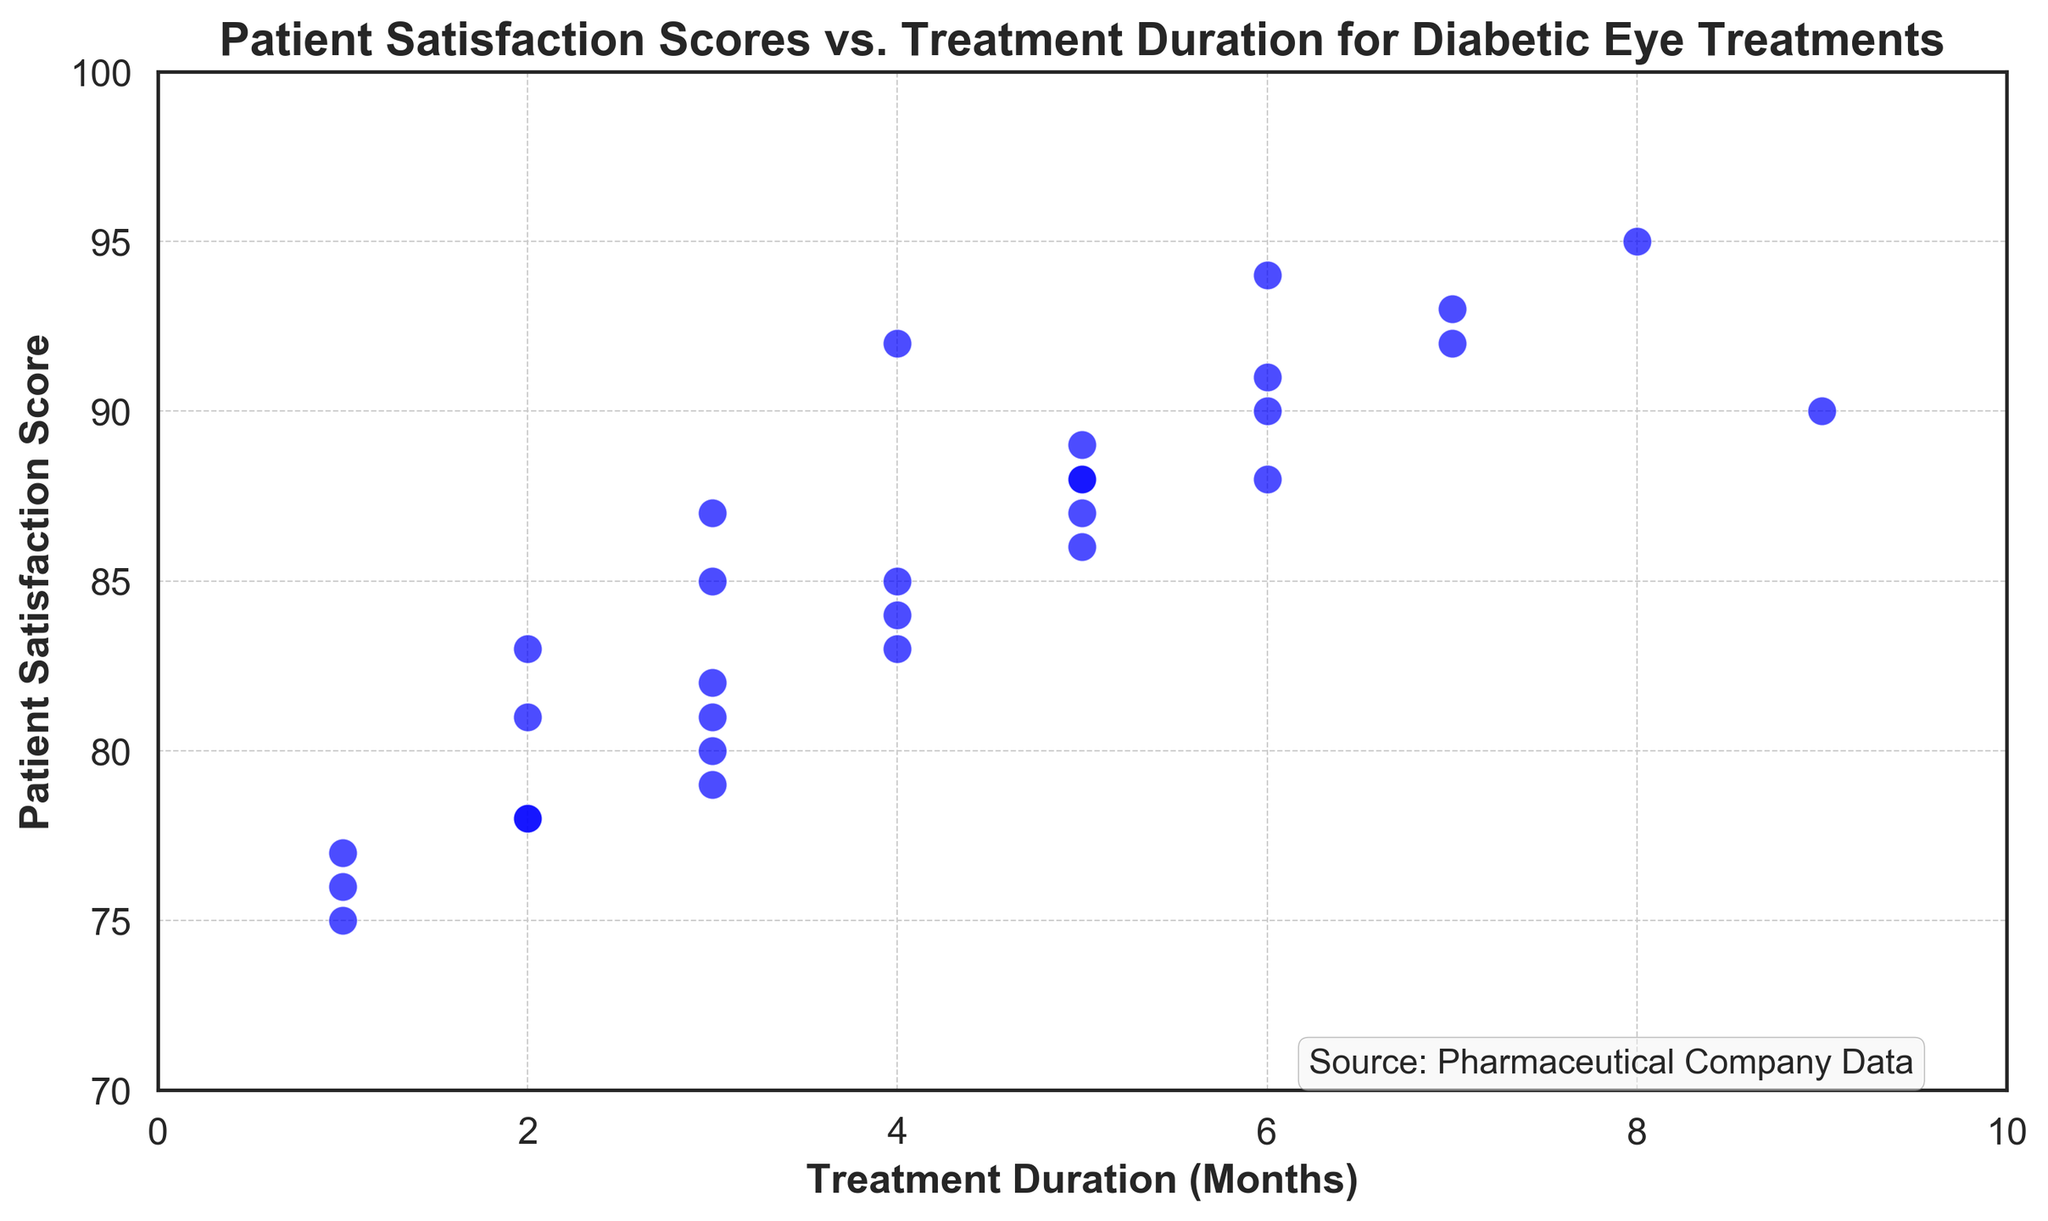What is the trend shown in the scatter plot between Patient Satisfaction Scores and Treatment Duration? To determine the trend, observe the overall direction of the data points. In the scatter plot, as the Treatment Duration months increase, the Patient Satisfaction Scores also generally appear to increase, indicating a positive correlation.
Answer: Positive correlation What is the Patient Satisfaction Score for a treatment duration of 5 months? To find this, locate the data point where the Treatment Duration is 5 months on the x-axis and then read the corresponding Patient Satisfaction Score on the y-axis. There's a data point at (5, 88).
Answer: 88 Which treatment duration corresponds to the highest Patient Satisfaction Score? Identify the highest point on the y-axis (Patient Satisfaction Scores) and find its corresponding x-axis value (Treatment Duration). The highest score is 95 at 8 months of treatment.
Answer: 8 months Is there any treatment duration that has a Patient Satisfaction Score below 80? If so, what are they? To answer this, observe the data points below the y-axis value of 80. There are points at approximately (2, 78), (1, 75), and (1, 77).
Answer: 2 months, 1 month, 1 month Do longer treatment durations consistently result in higher Patient Satisfaction Scores? To determine consistency, check if higher x-axis (longer durations) consistently correspond to higher y-axis (scores). While most longer durations tend to have higher scores, there are some exceptions (e.g., lower scores at intermediate durations). Thus, it's not entirely consistent.
Answer: No What is the average Patient Satisfaction Score for treatments with a duration of 7 months? Find all points with a Treatment Duration of 7 months and average their Satisfaction Scores. With the values given, the scores are 92, 89, 93, and 84. The average is (92 + 89 + 93 + 84) / 4 = 89.5.
Answer: 89.5 Compare the Patient Satisfaction Score for treatments of 3 months and 6 months duration. Which one is higher? Locate the scores for Treatment Durations of 3 months (85) and 6 months (90). Compare these values. The score for 6 months is higher.
Answer: 6 months How many treatment durations have a Patient Satisfaction Score of over 90? Count the number of data points where the y-axis value exceeds 90. There are six such points: (6, 90), (7, 92), (8, 95), (7, 93), (6, 93), and (7, 92).
Answer: 6 What is the difference between the highest and lowest Patient Satisfaction Scores? Identify the maximum score (95) and minimum score (75). Calculate the difference: 95 - 75.
Answer: 20 What is the median Patient Satisfaction Score for treatments of 4 months duration? Locate all data points with a 4-month duration and find the middle value. The scores for 4 months are 83, 85, 81. The median value (second value in ordered list) is 83.
Answer: 83 